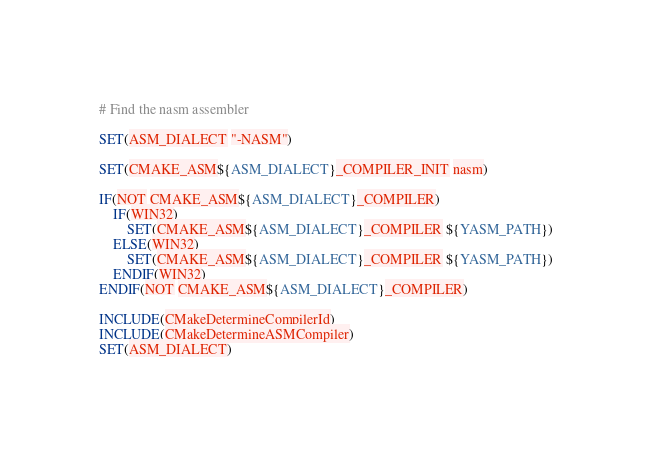Convert code to text. <code><loc_0><loc_0><loc_500><loc_500><_CMake_># Find the nasm assembler

SET(ASM_DIALECT "-NASM")

SET(CMAKE_ASM${ASM_DIALECT}_COMPILER_INIT nasm)

IF(NOT CMAKE_ASM${ASM_DIALECT}_COMPILER)
	IF(WIN32)
		SET(CMAKE_ASM${ASM_DIALECT}_COMPILER ${YASM_PATH})
	ELSE(WIN32)
		SET(CMAKE_ASM${ASM_DIALECT}_COMPILER ${YASM_PATH})
	ENDIF(WIN32)
ENDIF(NOT CMAKE_ASM${ASM_DIALECT}_COMPILER)

INCLUDE(CMakeDetermineCompilerId)
INCLUDE(CMakeDetermineASMCompiler)
SET(ASM_DIALECT)</code> 